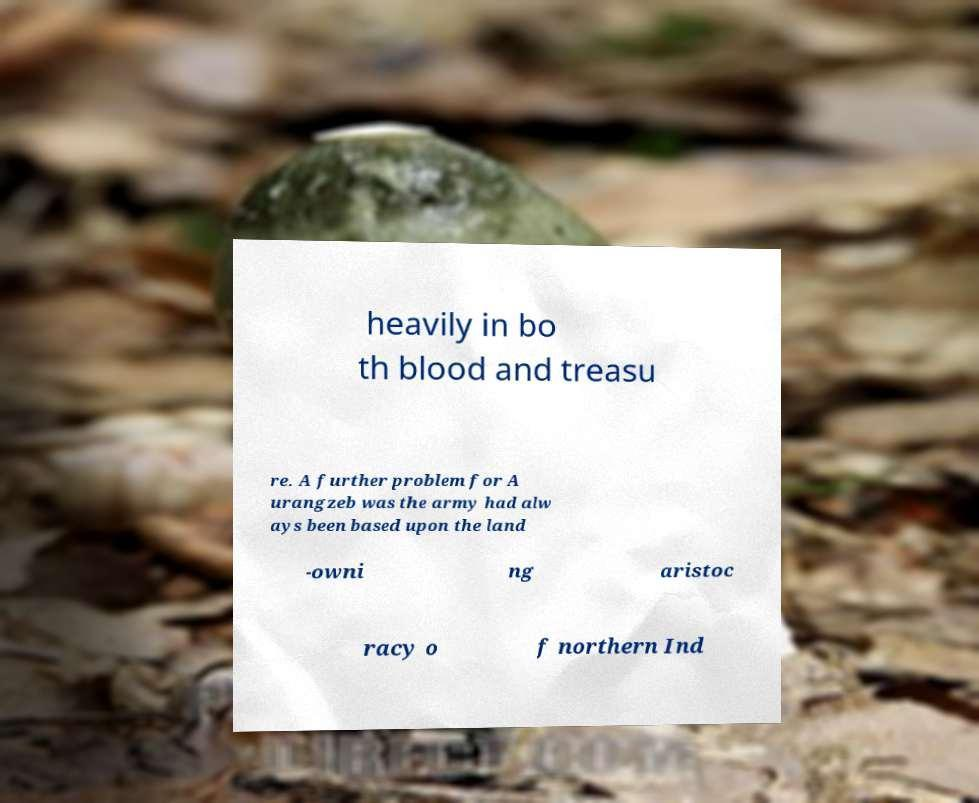Can you accurately transcribe the text from the provided image for me? heavily in bo th blood and treasu re. A further problem for A urangzeb was the army had alw ays been based upon the land -owni ng aristoc racy o f northern Ind 